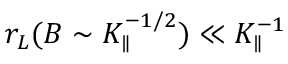Convert formula to latex. <formula><loc_0><loc_0><loc_500><loc_500>r _ { L } ( B \sim K _ { \| } ^ { - 1 / 2 } ) \ll K _ { \| } ^ { - 1 }</formula> 